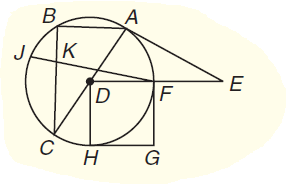Answer the mathemtical geometry problem and directly provide the correct option letter.
Question: A E is a tangent. If A D = 12 and F E = 18, how long is A E to the nearest tenth unit?
Choices: A: 27.5 B: 55 C: 60 D: 90 A 